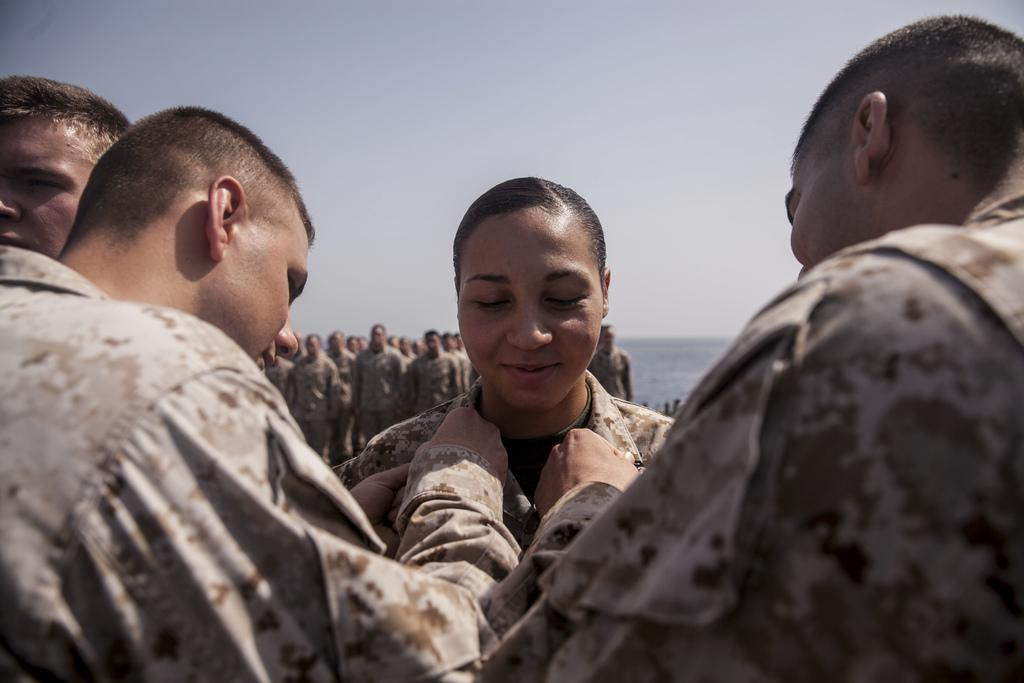What is happening in the image? There are people standing in the image. Can you describe the background of the image? In the background, there are people standing in a queue. What is visible at the top of the image? The sky is visible at the top of the image. What type of sand can be seen on the rings in the image? There are no rings or sand present in the image. How does the transport system look like in the image? There is no transport system visible in the image; it only shows people standing and a queue in the background. 